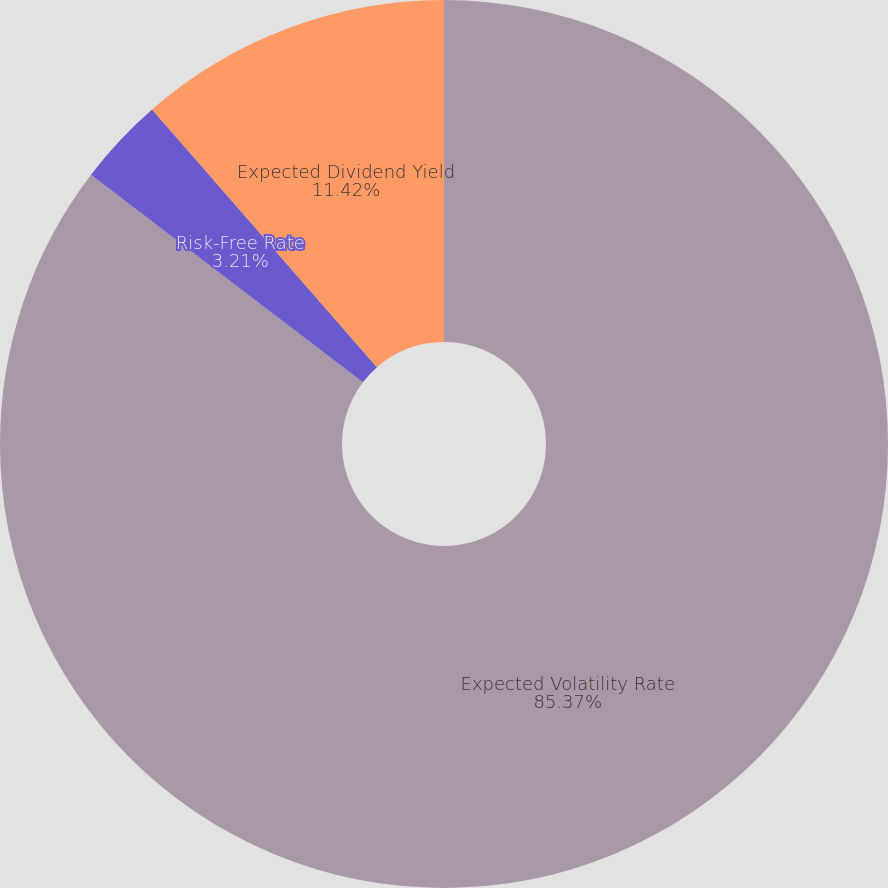<chart> <loc_0><loc_0><loc_500><loc_500><pie_chart><fcel>Expected Volatility Rate<fcel>Risk-Free Rate<fcel>Expected Dividend Yield<nl><fcel>85.37%<fcel>3.21%<fcel>11.42%<nl></chart> 